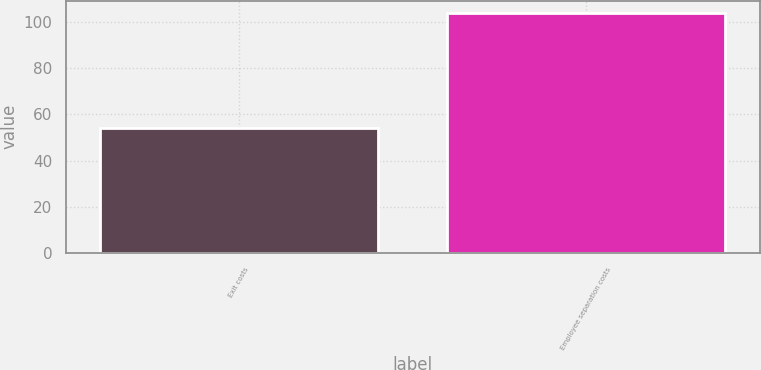Convert chart to OTSL. <chart><loc_0><loc_0><loc_500><loc_500><bar_chart><fcel>Exit costs<fcel>Employee separation costs<nl><fcel>54<fcel>104<nl></chart> 